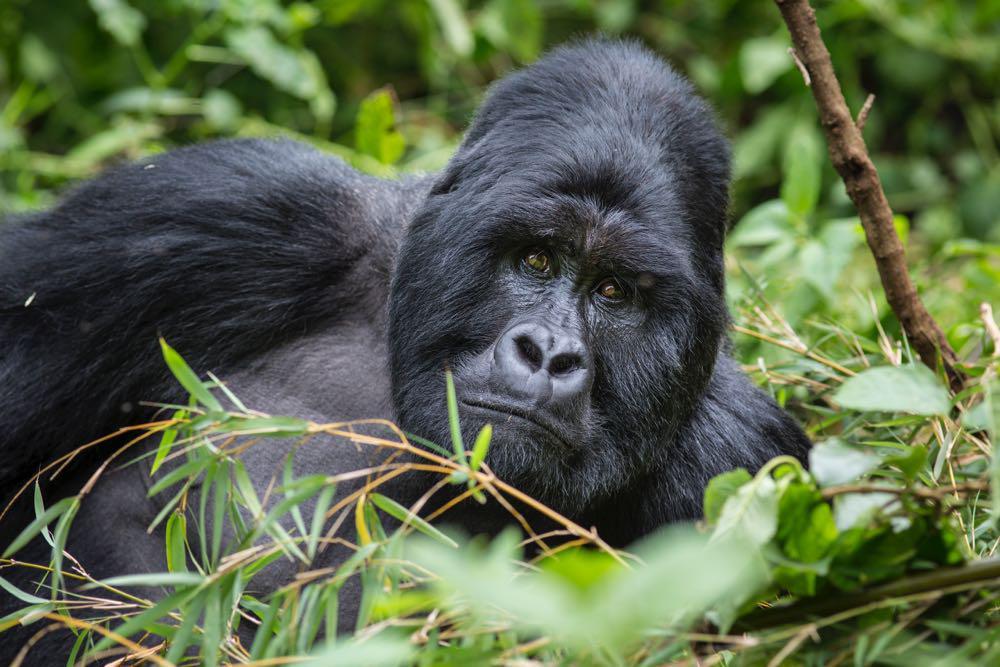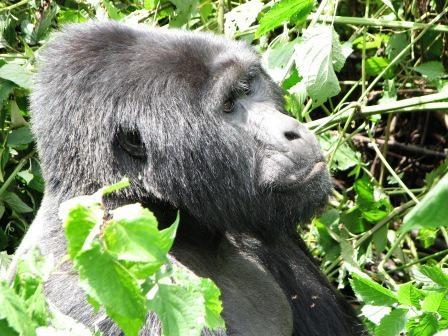The first image is the image on the left, the second image is the image on the right. Examine the images to the left and right. Is the description "One ape is laying on its stomach." accurate? Answer yes or no. No. The first image is the image on the left, the second image is the image on the right. Assess this claim about the two images: "One image shows a forward-gazing gorilla reclining on its side with its head to the right, and the other image features a rightward-facing gorilla with its head in profile.". Correct or not? Answer yes or no. Yes. 